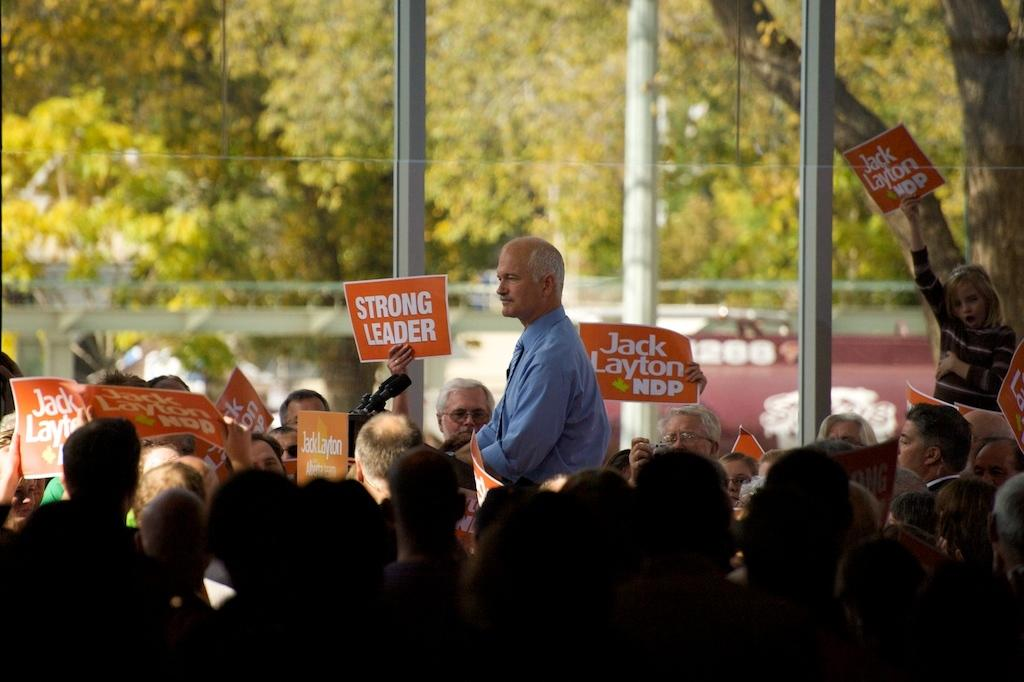What are the people in the image doing? The people in the image are standing and holding posters. What can be seen in the background of the image? There are green color trees in the background of the image. Can you tell me how many goats are visible in the image? There are no goats present in the image. What type of potato is being used as a prop in the image? There is no potato present in the image. 